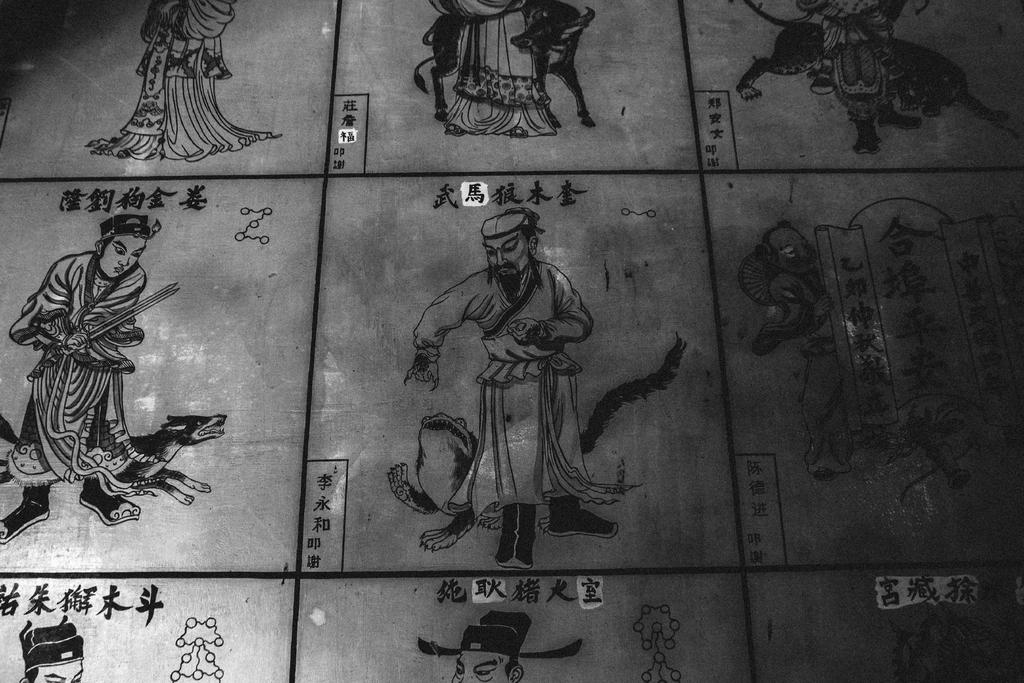What is the main subject of the image? The main subject of the image is a stone carving. What does the stone carving depict? The stone carving depicts people. Are there any additional elements included in the stone carving? Yes, the stone carving includes letters. What type of oven can be seen in the background of the image? There is no oven present in the image; it features a stone carving depicting people and letters. How many children were born during the event depicted in the stone carving? The image does not provide information about any events or births; it only shows a stone carving with people and letters. 